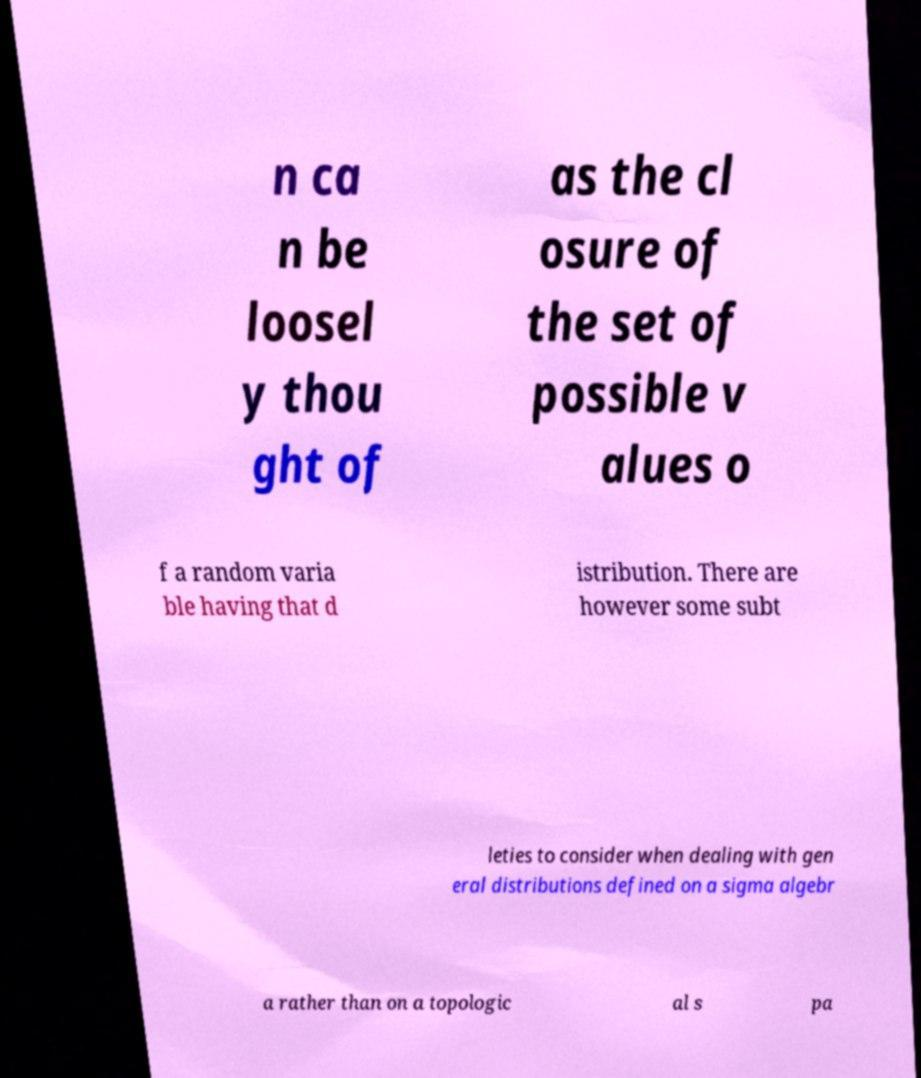For documentation purposes, I need the text within this image transcribed. Could you provide that? n ca n be loosel y thou ght of as the cl osure of the set of possible v alues o f a random varia ble having that d istribution. There are however some subt leties to consider when dealing with gen eral distributions defined on a sigma algebr a rather than on a topologic al s pa 